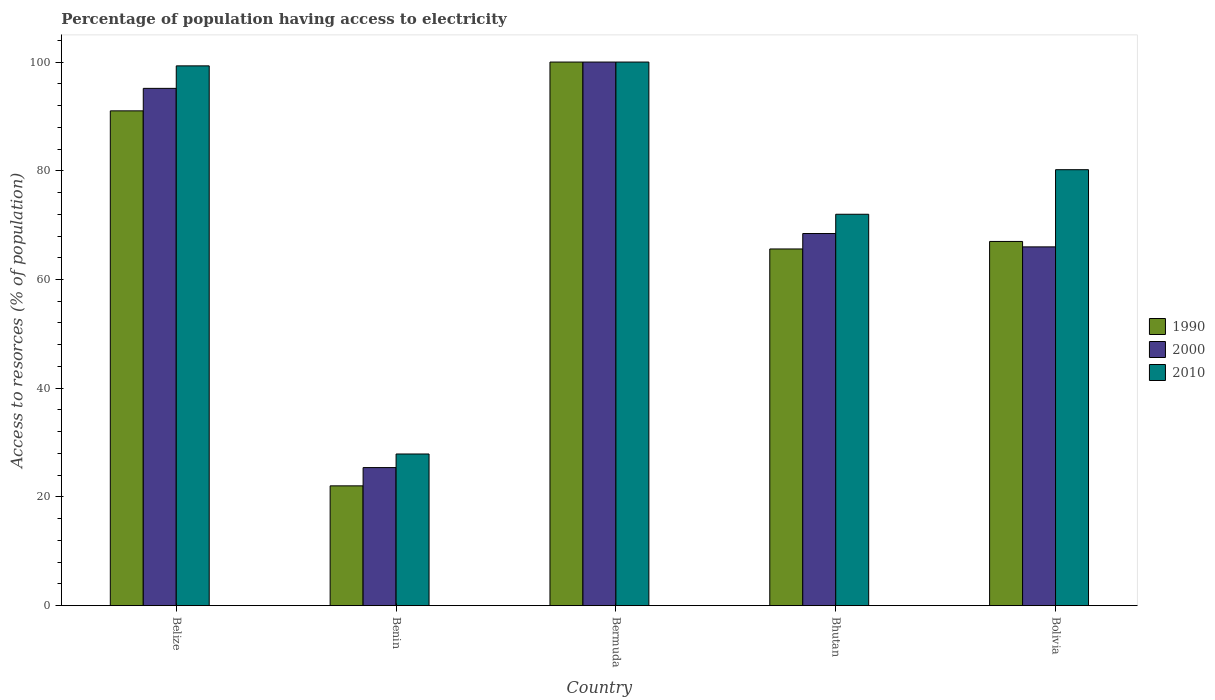What is the label of the 2nd group of bars from the left?
Your answer should be very brief. Benin. In how many cases, is the number of bars for a given country not equal to the number of legend labels?
Give a very brief answer. 0. What is the percentage of population having access to electricity in 2000 in Bhutan?
Ensure brevity in your answer.  68.46. Across all countries, what is the maximum percentage of population having access to electricity in 1990?
Your answer should be very brief. 100. Across all countries, what is the minimum percentage of population having access to electricity in 2010?
Provide a short and direct response. 27.9. In which country was the percentage of population having access to electricity in 2000 maximum?
Provide a succinct answer. Bermuda. In which country was the percentage of population having access to electricity in 2010 minimum?
Keep it short and to the point. Benin. What is the total percentage of population having access to electricity in 2000 in the graph?
Keep it short and to the point. 355.02. What is the difference between the percentage of population having access to electricity in 1990 in Benin and that in Bermuda?
Give a very brief answer. -77.96. What is the difference between the percentage of population having access to electricity in 2000 in Belize and the percentage of population having access to electricity in 1990 in Bolivia?
Give a very brief answer. 28.16. What is the average percentage of population having access to electricity in 2010 per country?
Offer a terse response. 75.88. What is the difference between the percentage of population having access to electricity of/in 2010 and percentage of population having access to electricity of/in 2000 in Bolivia?
Give a very brief answer. 14.2. In how many countries, is the percentage of population having access to electricity in 1990 greater than 40 %?
Provide a succinct answer. 4. What is the ratio of the percentage of population having access to electricity in 1990 in Belize to that in Bhutan?
Give a very brief answer. 1.39. Is the percentage of population having access to electricity in 1990 in Benin less than that in Bolivia?
Provide a succinct answer. Yes. What is the difference between the highest and the second highest percentage of population having access to electricity in 1990?
Your answer should be very brief. -24.02. What is the difference between the highest and the lowest percentage of population having access to electricity in 2000?
Provide a succinct answer. 74.6. In how many countries, is the percentage of population having access to electricity in 1990 greater than the average percentage of population having access to electricity in 1990 taken over all countries?
Your response must be concise. 2. What does the 2nd bar from the right in Bolivia represents?
Offer a very short reply. 2000. Is it the case that in every country, the sum of the percentage of population having access to electricity in 2010 and percentage of population having access to electricity in 2000 is greater than the percentage of population having access to electricity in 1990?
Offer a terse response. Yes. What is the difference between two consecutive major ticks on the Y-axis?
Offer a terse response. 20. Does the graph contain grids?
Provide a succinct answer. No. Where does the legend appear in the graph?
Offer a terse response. Center right. What is the title of the graph?
Offer a terse response. Percentage of population having access to electricity. Does "2011" appear as one of the legend labels in the graph?
Keep it short and to the point. No. What is the label or title of the Y-axis?
Keep it short and to the point. Access to resorces (% of population). What is the Access to resorces (% of population) in 1990 in Belize?
Ensure brevity in your answer.  91.02. What is the Access to resorces (% of population) in 2000 in Belize?
Your answer should be compact. 95.16. What is the Access to resorces (% of population) of 2010 in Belize?
Provide a succinct answer. 99.3. What is the Access to resorces (% of population) in 1990 in Benin?
Ensure brevity in your answer.  22.04. What is the Access to resorces (% of population) of 2000 in Benin?
Provide a short and direct response. 25.4. What is the Access to resorces (% of population) of 2010 in Benin?
Make the answer very short. 27.9. What is the Access to resorces (% of population) of 2000 in Bermuda?
Ensure brevity in your answer.  100. What is the Access to resorces (% of population) of 1990 in Bhutan?
Your answer should be very brief. 65.62. What is the Access to resorces (% of population) in 2000 in Bhutan?
Make the answer very short. 68.46. What is the Access to resorces (% of population) in 2010 in Bolivia?
Your answer should be very brief. 80.2. Across all countries, what is the minimum Access to resorces (% of population) in 1990?
Keep it short and to the point. 22.04. Across all countries, what is the minimum Access to resorces (% of population) in 2000?
Your answer should be compact. 25.4. Across all countries, what is the minimum Access to resorces (% of population) in 2010?
Your answer should be very brief. 27.9. What is the total Access to resorces (% of population) of 1990 in the graph?
Keep it short and to the point. 345.68. What is the total Access to resorces (% of population) of 2000 in the graph?
Give a very brief answer. 355.02. What is the total Access to resorces (% of population) of 2010 in the graph?
Provide a short and direct response. 379.4. What is the difference between the Access to resorces (% of population) in 1990 in Belize and that in Benin?
Keep it short and to the point. 68.98. What is the difference between the Access to resorces (% of population) of 2000 in Belize and that in Benin?
Ensure brevity in your answer.  69.76. What is the difference between the Access to resorces (% of population) in 2010 in Belize and that in Benin?
Provide a succinct answer. 71.4. What is the difference between the Access to resorces (% of population) in 1990 in Belize and that in Bermuda?
Offer a terse response. -8.98. What is the difference between the Access to resorces (% of population) in 2000 in Belize and that in Bermuda?
Offer a very short reply. -4.84. What is the difference between the Access to resorces (% of population) in 1990 in Belize and that in Bhutan?
Give a very brief answer. 25.41. What is the difference between the Access to resorces (% of population) in 2000 in Belize and that in Bhutan?
Keep it short and to the point. 26.71. What is the difference between the Access to resorces (% of population) in 2010 in Belize and that in Bhutan?
Keep it short and to the point. 27.3. What is the difference between the Access to resorces (% of population) of 1990 in Belize and that in Bolivia?
Your response must be concise. 24.02. What is the difference between the Access to resorces (% of population) of 2000 in Belize and that in Bolivia?
Offer a terse response. 29.16. What is the difference between the Access to resorces (% of population) in 2010 in Belize and that in Bolivia?
Offer a terse response. 19.1. What is the difference between the Access to resorces (% of population) in 1990 in Benin and that in Bermuda?
Your answer should be very brief. -77.96. What is the difference between the Access to resorces (% of population) of 2000 in Benin and that in Bermuda?
Offer a very short reply. -74.6. What is the difference between the Access to resorces (% of population) of 2010 in Benin and that in Bermuda?
Make the answer very short. -72.1. What is the difference between the Access to resorces (% of population) in 1990 in Benin and that in Bhutan?
Offer a terse response. -43.58. What is the difference between the Access to resorces (% of population) in 2000 in Benin and that in Bhutan?
Make the answer very short. -43.06. What is the difference between the Access to resorces (% of population) in 2010 in Benin and that in Bhutan?
Give a very brief answer. -44.1. What is the difference between the Access to resorces (% of population) of 1990 in Benin and that in Bolivia?
Make the answer very short. -44.96. What is the difference between the Access to resorces (% of population) of 2000 in Benin and that in Bolivia?
Make the answer very short. -40.6. What is the difference between the Access to resorces (% of population) of 2010 in Benin and that in Bolivia?
Give a very brief answer. -52.3. What is the difference between the Access to resorces (% of population) of 1990 in Bermuda and that in Bhutan?
Give a very brief answer. 34.38. What is the difference between the Access to resorces (% of population) of 2000 in Bermuda and that in Bhutan?
Your response must be concise. 31.54. What is the difference between the Access to resorces (% of population) of 2010 in Bermuda and that in Bolivia?
Ensure brevity in your answer.  19.8. What is the difference between the Access to resorces (% of population) in 1990 in Bhutan and that in Bolivia?
Give a very brief answer. -1.38. What is the difference between the Access to resorces (% of population) of 2000 in Bhutan and that in Bolivia?
Your answer should be compact. 2.46. What is the difference between the Access to resorces (% of population) of 1990 in Belize and the Access to resorces (% of population) of 2000 in Benin?
Make the answer very short. 65.62. What is the difference between the Access to resorces (% of population) of 1990 in Belize and the Access to resorces (% of population) of 2010 in Benin?
Provide a short and direct response. 63.12. What is the difference between the Access to resorces (% of population) of 2000 in Belize and the Access to resorces (% of population) of 2010 in Benin?
Give a very brief answer. 67.26. What is the difference between the Access to resorces (% of population) in 1990 in Belize and the Access to resorces (% of population) in 2000 in Bermuda?
Provide a short and direct response. -8.98. What is the difference between the Access to resorces (% of population) of 1990 in Belize and the Access to resorces (% of population) of 2010 in Bermuda?
Keep it short and to the point. -8.98. What is the difference between the Access to resorces (% of population) of 2000 in Belize and the Access to resorces (% of population) of 2010 in Bermuda?
Your answer should be compact. -4.84. What is the difference between the Access to resorces (% of population) of 1990 in Belize and the Access to resorces (% of population) of 2000 in Bhutan?
Provide a succinct answer. 22.57. What is the difference between the Access to resorces (% of population) of 1990 in Belize and the Access to resorces (% of population) of 2010 in Bhutan?
Make the answer very short. 19.02. What is the difference between the Access to resorces (% of population) of 2000 in Belize and the Access to resorces (% of population) of 2010 in Bhutan?
Keep it short and to the point. 23.16. What is the difference between the Access to resorces (% of population) in 1990 in Belize and the Access to resorces (% of population) in 2000 in Bolivia?
Make the answer very short. 25.02. What is the difference between the Access to resorces (% of population) in 1990 in Belize and the Access to resorces (% of population) in 2010 in Bolivia?
Your answer should be compact. 10.82. What is the difference between the Access to resorces (% of population) of 2000 in Belize and the Access to resorces (% of population) of 2010 in Bolivia?
Make the answer very short. 14.96. What is the difference between the Access to resorces (% of population) in 1990 in Benin and the Access to resorces (% of population) in 2000 in Bermuda?
Provide a short and direct response. -77.96. What is the difference between the Access to resorces (% of population) of 1990 in Benin and the Access to resorces (% of population) of 2010 in Bermuda?
Ensure brevity in your answer.  -77.96. What is the difference between the Access to resorces (% of population) in 2000 in Benin and the Access to resorces (% of population) in 2010 in Bermuda?
Make the answer very short. -74.6. What is the difference between the Access to resorces (% of population) in 1990 in Benin and the Access to resorces (% of population) in 2000 in Bhutan?
Offer a very short reply. -46.42. What is the difference between the Access to resorces (% of population) of 1990 in Benin and the Access to resorces (% of population) of 2010 in Bhutan?
Make the answer very short. -49.96. What is the difference between the Access to resorces (% of population) in 2000 in Benin and the Access to resorces (% of population) in 2010 in Bhutan?
Provide a succinct answer. -46.6. What is the difference between the Access to resorces (% of population) in 1990 in Benin and the Access to resorces (% of population) in 2000 in Bolivia?
Your answer should be very brief. -43.96. What is the difference between the Access to resorces (% of population) in 1990 in Benin and the Access to resorces (% of population) in 2010 in Bolivia?
Offer a very short reply. -58.16. What is the difference between the Access to resorces (% of population) in 2000 in Benin and the Access to resorces (% of population) in 2010 in Bolivia?
Provide a short and direct response. -54.8. What is the difference between the Access to resorces (% of population) in 1990 in Bermuda and the Access to resorces (% of population) in 2000 in Bhutan?
Give a very brief answer. 31.54. What is the difference between the Access to resorces (% of population) of 1990 in Bermuda and the Access to resorces (% of population) of 2010 in Bhutan?
Provide a short and direct response. 28. What is the difference between the Access to resorces (% of population) in 1990 in Bermuda and the Access to resorces (% of population) in 2000 in Bolivia?
Your response must be concise. 34. What is the difference between the Access to resorces (% of population) in 1990 in Bermuda and the Access to resorces (% of population) in 2010 in Bolivia?
Keep it short and to the point. 19.8. What is the difference between the Access to resorces (% of population) of 2000 in Bermuda and the Access to resorces (% of population) of 2010 in Bolivia?
Offer a very short reply. 19.8. What is the difference between the Access to resorces (% of population) of 1990 in Bhutan and the Access to resorces (% of population) of 2000 in Bolivia?
Ensure brevity in your answer.  -0.38. What is the difference between the Access to resorces (% of population) of 1990 in Bhutan and the Access to resorces (% of population) of 2010 in Bolivia?
Offer a terse response. -14.58. What is the difference between the Access to resorces (% of population) in 2000 in Bhutan and the Access to resorces (% of population) in 2010 in Bolivia?
Provide a short and direct response. -11.74. What is the average Access to resorces (% of population) in 1990 per country?
Provide a short and direct response. 69.14. What is the average Access to resorces (% of population) of 2000 per country?
Provide a short and direct response. 71. What is the average Access to resorces (% of population) of 2010 per country?
Your answer should be compact. 75.88. What is the difference between the Access to resorces (% of population) of 1990 and Access to resorces (% of population) of 2000 in Belize?
Make the answer very short. -4.14. What is the difference between the Access to resorces (% of population) in 1990 and Access to resorces (% of population) in 2010 in Belize?
Make the answer very short. -8.28. What is the difference between the Access to resorces (% of population) of 2000 and Access to resorces (% of population) of 2010 in Belize?
Offer a terse response. -4.14. What is the difference between the Access to resorces (% of population) in 1990 and Access to resorces (% of population) in 2000 in Benin?
Your answer should be compact. -3.36. What is the difference between the Access to resorces (% of population) of 1990 and Access to resorces (% of population) of 2010 in Benin?
Provide a short and direct response. -5.86. What is the difference between the Access to resorces (% of population) in 2000 and Access to resorces (% of population) in 2010 in Benin?
Provide a succinct answer. -2.5. What is the difference between the Access to resorces (% of population) of 1990 and Access to resorces (% of population) of 2010 in Bermuda?
Provide a short and direct response. 0. What is the difference between the Access to resorces (% of population) of 2000 and Access to resorces (% of population) of 2010 in Bermuda?
Provide a short and direct response. 0. What is the difference between the Access to resorces (% of population) of 1990 and Access to resorces (% of population) of 2000 in Bhutan?
Provide a short and direct response. -2.84. What is the difference between the Access to resorces (% of population) in 1990 and Access to resorces (% of population) in 2010 in Bhutan?
Ensure brevity in your answer.  -6.38. What is the difference between the Access to resorces (% of population) in 2000 and Access to resorces (% of population) in 2010 in Bhutan?
Your response must be concise. -3.54. What is the difference between the Access to resorces (% of population) of 1990 and Access to resorces (% of population) of 2000 in Bolivia?
Your answer should be compact. 1. What is the difference between the Access to resorces (% of population) in 2000 and Access to resorces (% of population) in 2010 in Bolivia?
Give a very brief answer. -14.2. What is the ratio of the Access to resorces (% of population) of 1990 in Belize to that in Benin?
Give a very brief answer. 4.13. What is the ratio of the Access to resorces (% of population) of 2000 in Belize to that in Benin?
Provide a short and direct response. 3.75. What is the ratio of the Access to resorces (% of population) in 2010 in Belize to that in Benin?
Give a very brief answer. 3.56. What is the ratio of the Access to resorces (% of population) in 1990 in Belize to that in Bermuda?
Keep it short and to the point. 0.91. What is the ratio of the Access to resorces (% of population) in 2000 in Belize to that in Bermuda?
Ensure brevity in your answer.  0.95. What is the ratio of the Access to resorces (% of population) of 1990 in Belize to that in Bhutan?
Make the answer very short. 1.39. What is the ratio of the Access to resorces (% of population) in 2000 in Belize to that in Bhutan?
Keep it short and to the point. 1.39. What is the ratio of the Access to resorces (% of population) in 2010 in Belize to that in Bhutan?
Keep it short and to the point. 1.38. What is the ratio of the Access to resorces (% of population) in 1990 in Belize to that in Bolivia?
Make the answer very short. 1.36. What is the ratio of the Access to resorces (% of population) in 2000 in Belize to that in Bolivia?
Provide a short and direct response. 1.44. What is the ratio of the Access to resorces (% of population) of 2010 in Belize to that in Bolivia?
Your response must be concise. 1.24. What is the ratio of the Access to resorces (% of population) in 1990 in Benin to that in Bermuda?
Provide a succinct answer. 0.22. What is the ratio of the Access to resorces (% of population) in 2000 in Benin to that in Bermuda?
Offer a terse response. 0.25. What is the ratio of the Access to resorces (% of population) in 2010 in Benin to that in Bermuda?
Your answer should be very brief. 0.28. What is the ratio of the Access to resorces (% of population) of 1990 in Benin to that in Bhutan?
Ensure brevity in your answer.  0.34. What is the ratio of the Access to resorces (% of population) of 2000 in Benin to that in Bhutan?
Keep it short and to the point. 0.37. What is the ratio of the Access to resorces (% of population) of 2010 in Benin to that in Bhutan?
Offer a very short reply. 0.39. What is the ratio of the Access to resorces (% of population) in 1990 in Benin to that in Bolivia?
Your answer should be compact. 0.33. What is the ratio of the Access to resorces (% of population) in 2000 in Benin to that in Bolivia?
Your answer should be very brief. 0.38. What is the ratio of the Access to resorces (% of population) in 2010 in Benin to that in Bolivia?
Ensure brevity in your answer.  0.35. What is the ratio of the Access to resorces (% of population) of 1990 in Bermuda to that in Bhutan?
Provide a succinct answer. 1.52. What is the ratio of the Access to resorces (% of population) of 2000 in Bermuda to that in Bhutan?
Give a very brief answer. 1.46. What is the ratio of the Access to resorces (% of population) in 2010 in Bermuda to that in Bhutan?
Keep it short and to the point. 1.39. What is the ratio of the Access to resorces (% of population) in 1990 in Bermuda to that in Bolivia?
Your answer should be very brief. 1.49. What is the ratio of the Access to resorces (% of population) of 2000 in Bermuda to that in Bolivia?
Give a very brief answer. 1.52. What is the ratio of the Access to resorces (% of population) in 2010 in Bermuda to that in Bolivia?
Give a very brief answer. 1.25. What is the ratio of the Access to resorces (% of population) of 1990 in Bhutan to that in Bolivia?
Keep it short and to the point. 0.98. What is the ratio of the Access to resorces (% of population) in 2000 in Bhutan to that in Bolivia?
Offer a terse response. 1.04. What is the ratio of the Access to resorces (% of population) in 2010 in Bhutan to that in Bolivia?
Give a very brief answer. 0.9. What is the difference between the highest and the second highest Access to resorces (% of population) of 1990?
Provide a short and direct response. 8.98. What is the difference between the highest and the second highest Access to resorces (% of population) in 2000?
Offer a terse response. 4.84. What is the difference between the highest and the lowest Access to resorces (% of population) in 1990?
Your response must be concise. 77.96. What is the difference between the highest and the lowest Access to resorces (% of population) of 2000?
Provide a succinct answer. 74.6. What is the difference between the highest and the lowest Access to resorces (% of population) in 2010?
Provide a succinct answer. 72.1. 